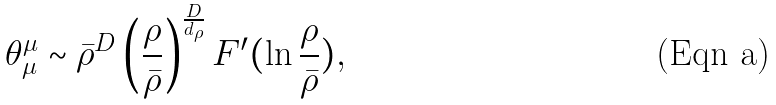Convert formula to latex. <formula><loc_0><loc_0><loc_500><loc_500>\theta _ { \mu } ^ { \mu } \sim \bar { \rho } ^ { D } \left ( \frac { \rho } { \bar { \rho } } \right ) ^ { \frac { D } { d _ { \rho } } } F ^ { \prime } ( \ln \frac { \rho } { \bar { \rho } } ) ,</formula> 